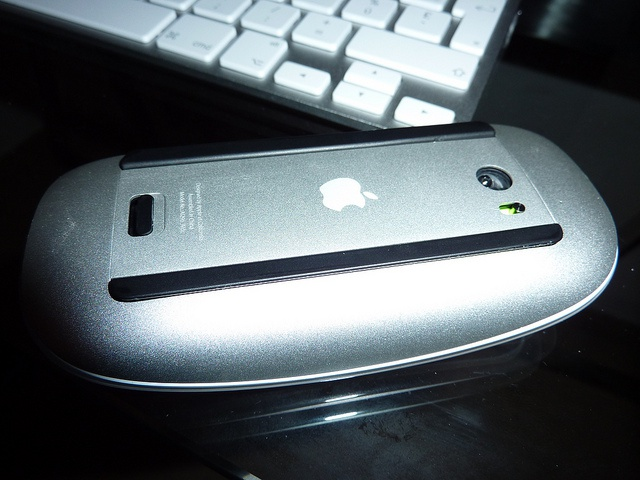Describe the objects in this image and their specific colors. I can see cell phone in purple, lightgray, darkgray, black, and lightblue tones and keyboard in darkblue, white, gray, lightblue, and darkgray tones in this image. 